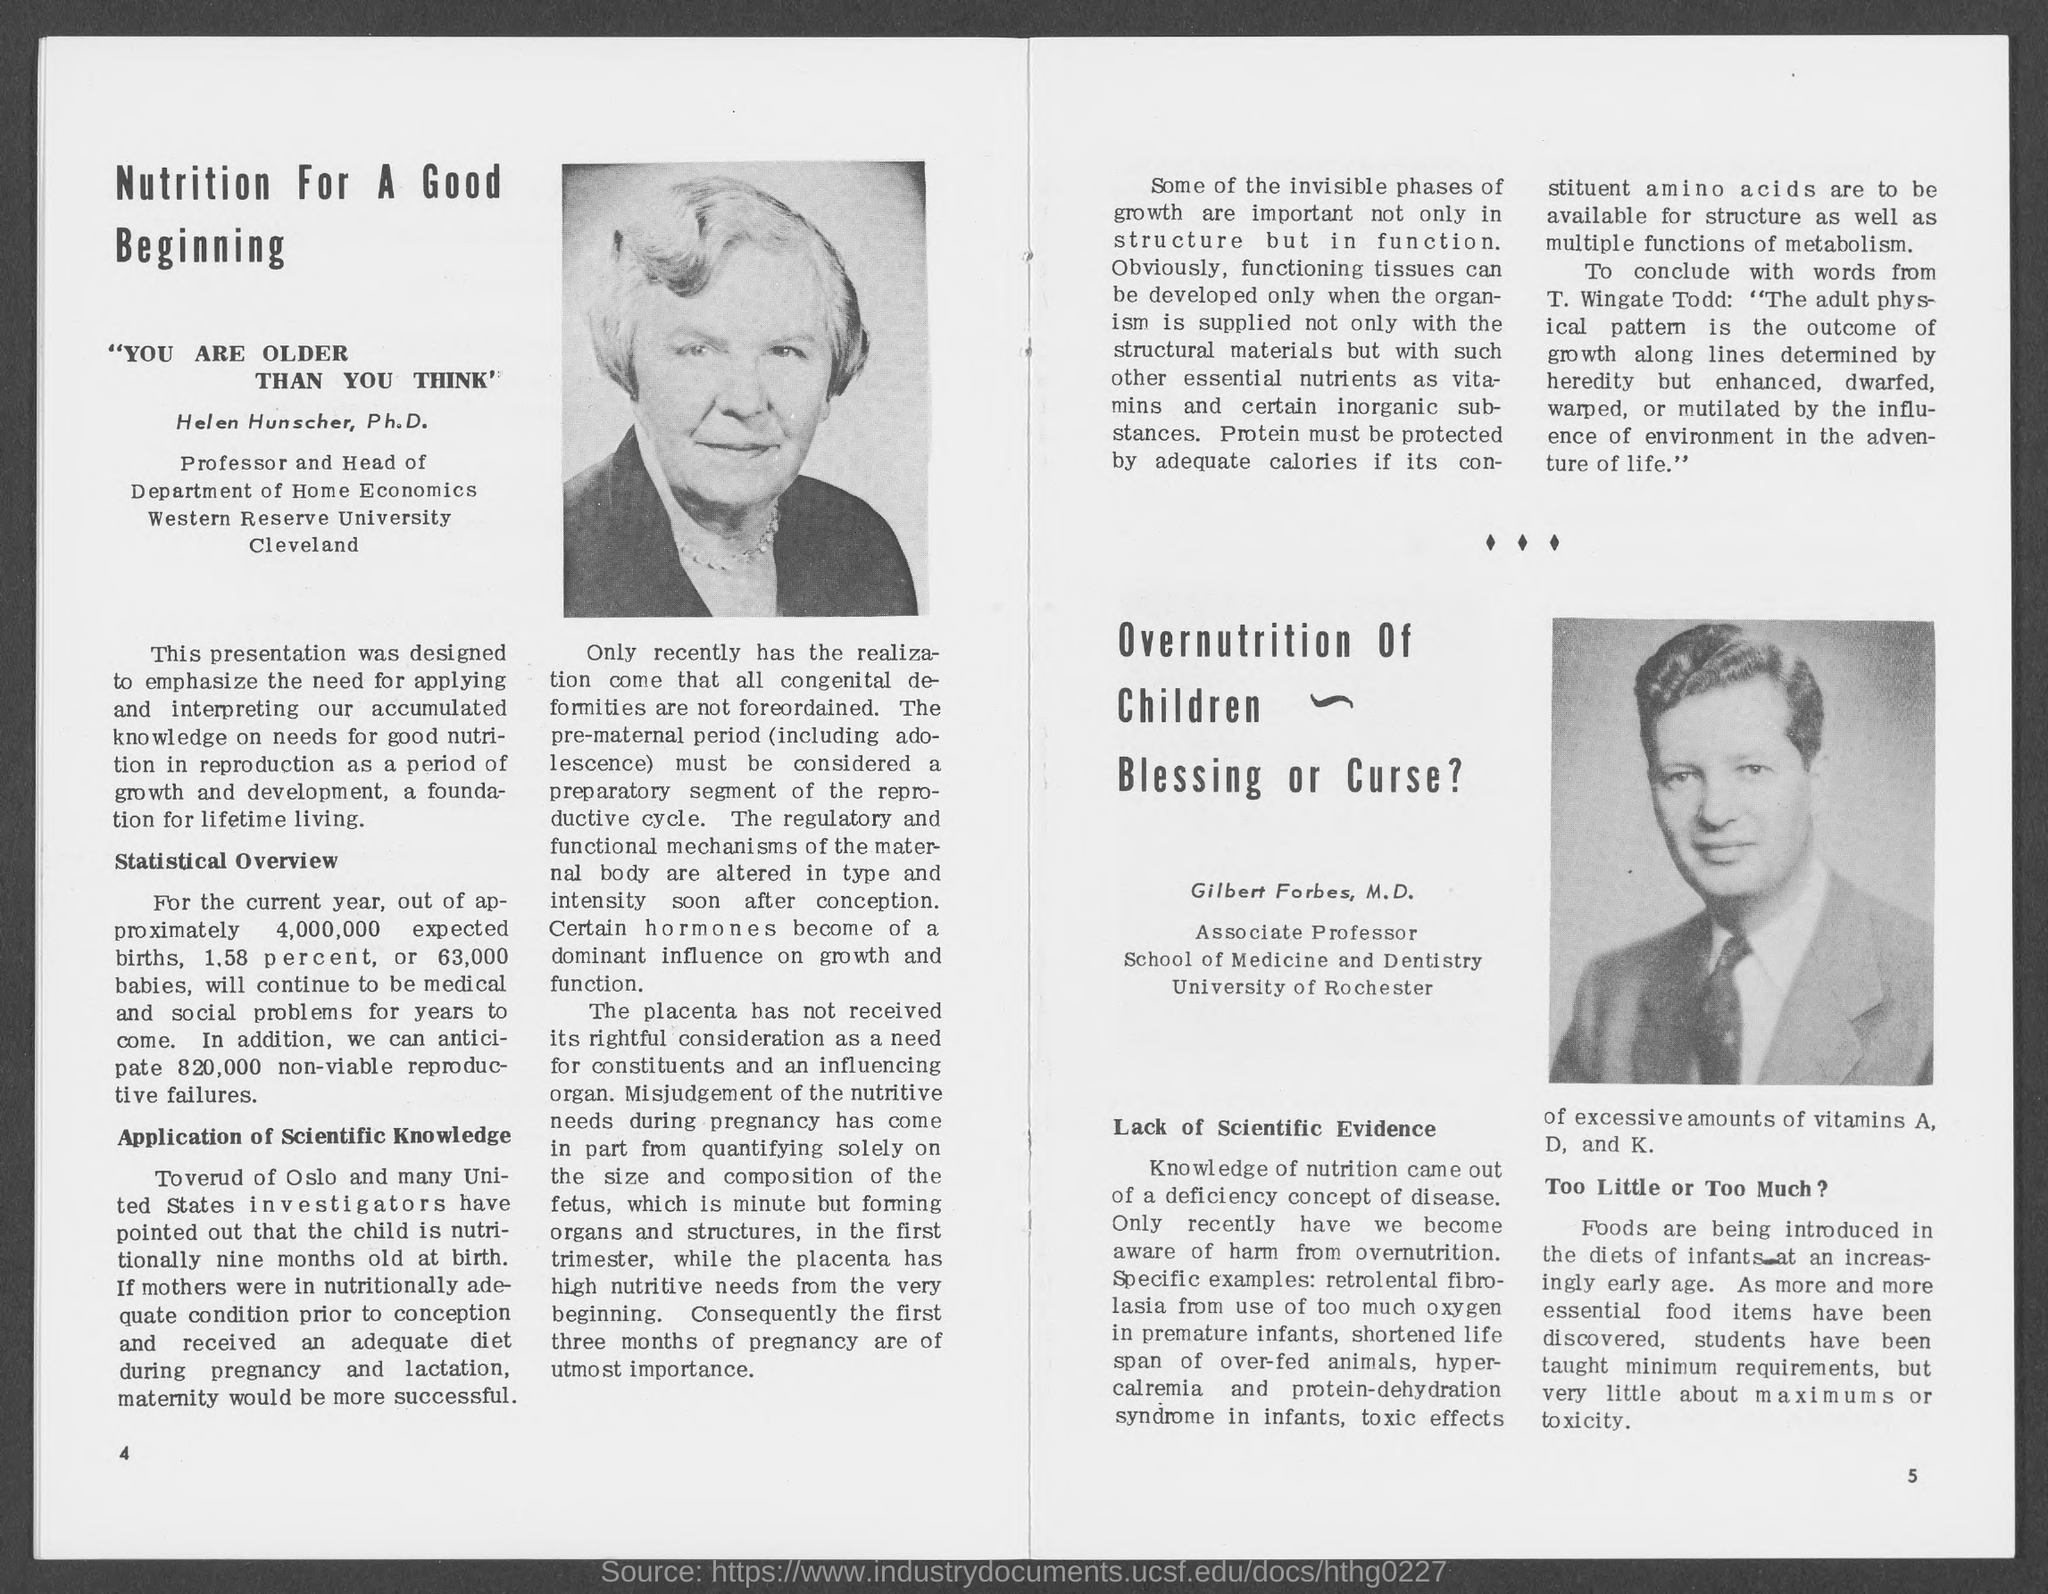Identify some key points in this picture. Helen works in the Department of Home Economics. Nutrition is crucial for a healthy and prosperous start in life, as it provides the necessary building blocks for growth and development. The name of the lady in the photo is Helen Hunscher, Ph.D. Gilbert is from the University of Rochester. It is projected that even with the introduction of the baby boxes, 1.58% of babies born with unexpectedly low birth weight will continue to be social or medical problems. 